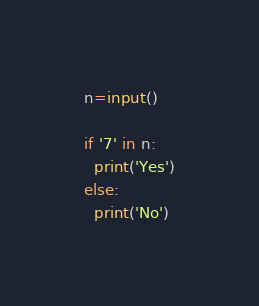Convert code to text. <code><loc_0><loc_0><loc_500><loc_500><_Python_>n=input()

if '7' in n:
  print('Yes')
else:
  print('No')</code> 